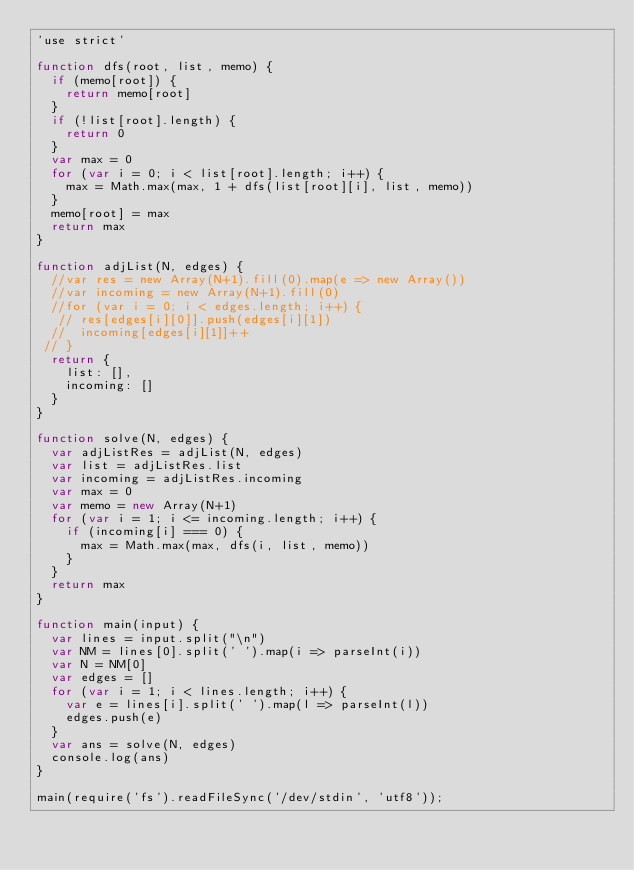Convert code to text. <code><loc_0><loc_0><loc_500><loc_500><_JavaScript_>'use strict'

function dfs(root, list, memo) {
  if (memo[root]) {
    return memo[root]
  }
  if (!list[root].length) {
    return 0
  }
  var max = 0
  for (var i = 0; i < list[root].length; i++) {
    max = Math.max(max, 1 + dfs(list[root][i], list, memo))
  }
  memo[root] = max
  return max
}

function adjList(N, edges) {
  //var res = new Array(N+1).fill(0).map(e => new Array())
  //var incoming = new Array(N+1).fill(0)
  //for (var i = 0; i < edges.length; i++) {
   // res[edges[i][0]].push(edges[i][1])
  //  incoming[edges[i][1]]++
 // }
  return {
    list: [],
    incoming: []
  }
}

function solve(N, edges) {
  var adjListRes = adjList(N, edges)
  var list = adjListRes.list
  var incoming = adjListRes.incoming
  var max = 0
  var memo = new Array(N+1)
  for (var i = 1; i <= incoming.length; i++) {
    if (incoming[i] === 0) {
      max = Math.max(max, dfs(i, list, memo))
    }
  }
  return max
}

function main(input) {
  var lines = input.split("\n")
  var NM = lines[0].split(' ').map(i => parseInt(i))
  var N = NM[0]
  var edges = []
  for (var i = 1; i < lines.length; i++) {
    var e = lines[i].split(' ').map(l => parseInt(l))
    edges.push(e)
  }
  var ans = solve(N, edges)
  console.log(ans)
}

main(require('fs').readFileSync('/dev/stdin', 'utf8'));</code> 